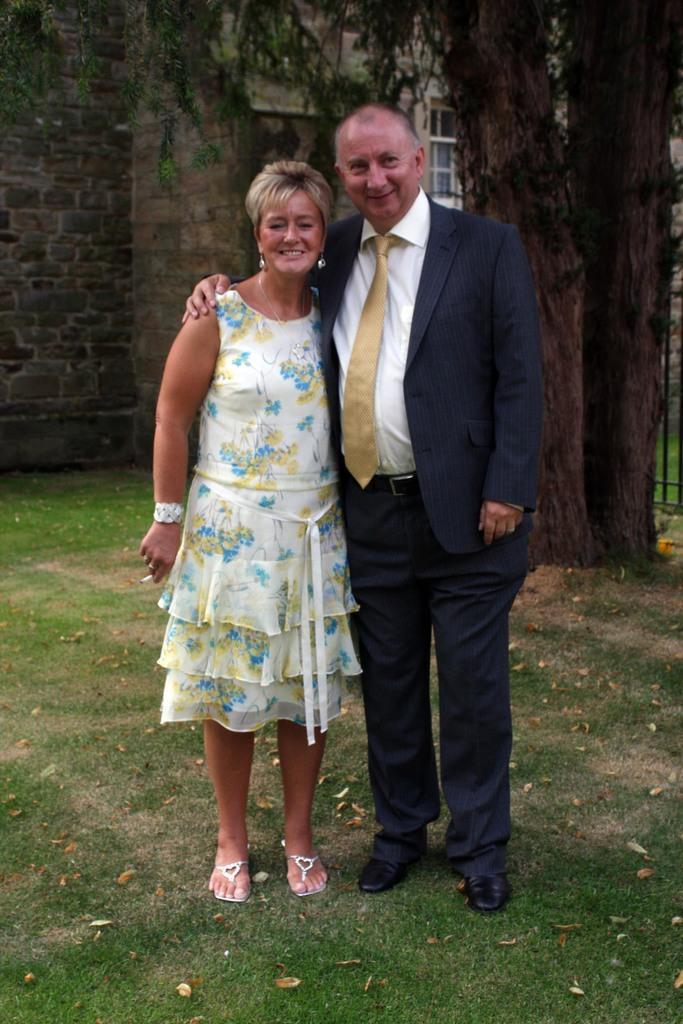Could you give a brief overview of what you see in this image? In the center of the image, we can see a man and a lady standing and one of them is wearing a coat and a tie and the other is holding a cigarette. In the background, there are trees and we can see a building. At the bottom, there is ground. 